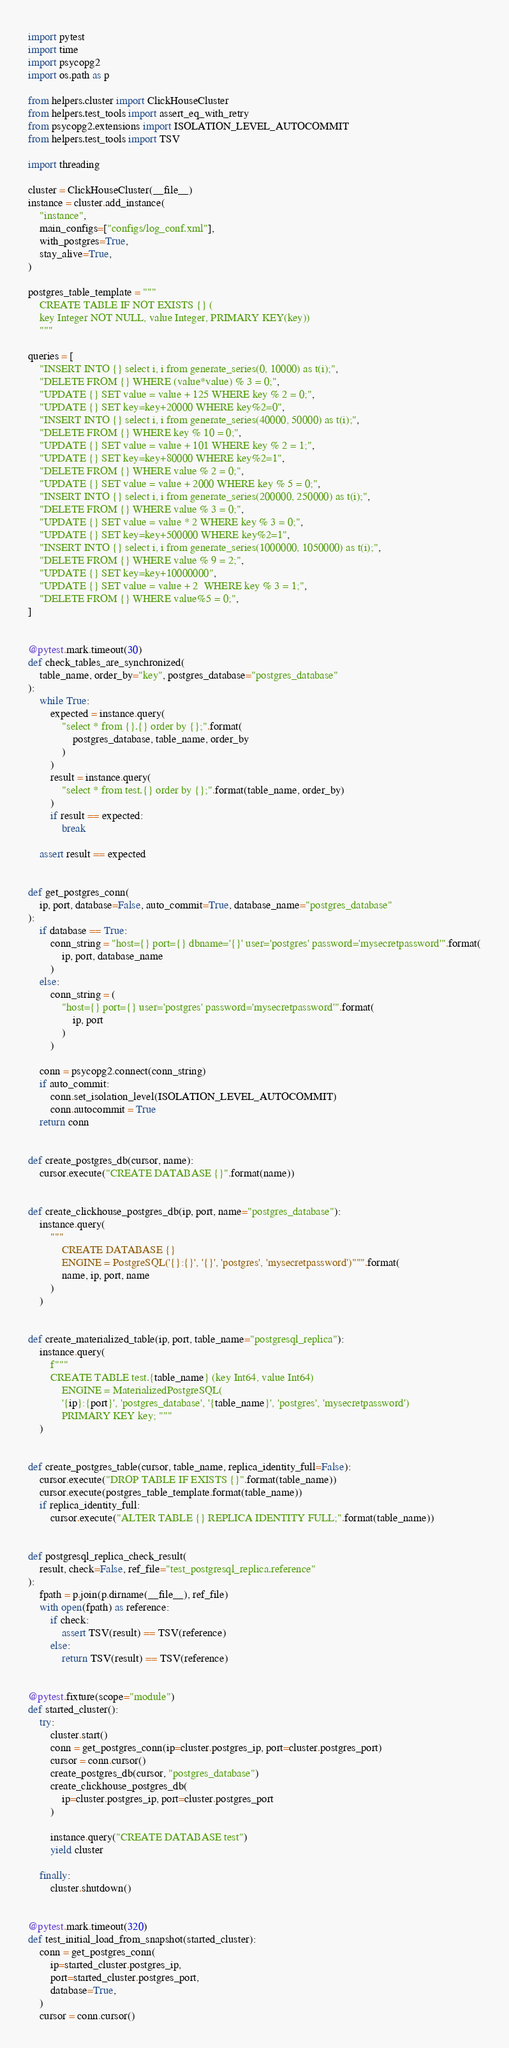<code> <loc_0><loc_0><loc_500><loc_500><_Python_>import pytest
import time
import psycopg2
import os.path as p

from helpers.cluster import ClickHouseCluster
from helpers.test_tools import assert_eq_with_retry
from psycopg2.extensions import ISOLATION_LEVEL_AUTOCOMMIT
from helpers.test_tools import TSV

import threading

cluster = ClickHouseCluster(__file__)
instance = cluster.add_instance(
    "instance",
    main_configs=["configs/log_conf.xml"],
    with_postgres=True,
    stay_alive=True,
)

postgres_table_template = """
    CREATE TABLE IF NOT EXISTS {} (
    key Integer NOT NULL, value Integer, PRIMARY KEY(key))
    """

queries = [
    "INSERT INTO {} select i, i from generate_series(0, 10000) as t(i);",
    "DELETE FROM {} WHERE (value*value) % 3 = 0;",
    "UPDATE {} SET value = value + 125 WHERE key % 2 = 0;",
    "UPDATE {} SET key=key+20000 WHERE key%2=0",
    "INSERT INTO {} select i, i from generate_series(40000, 50000) as t(i);",
    "DELETE FROM {} WHERE key % 10 = 0;",
    "UPDATE {} SET value = value + 101 WHERE key % 2 = 1;",
    "UPDATE {} SET key=key+80000 WHERE key%2=1",
    "DELETE FROM {} WHERE value % 2 = 0;",
    "UPDATE {} SET value = value + 2000 WHERE key % 5 = 0;",
    "INSERT INTO {} select i, i from generate_series(200000, 250000) as t(i);",
    "DELETE FROM {} WHERE value % 3 = 0;",
    "UPDATE {} SET value = value * 2 WHERE key % 3 = 0;",
    "UPDATE {} SET key=key+500000 WHERE key%2=1",
    "INSERT INTO {} select i, i from generate_series(1000000, 1050000) as t(i);",
    "DELETE FROM {} WHERE value % 9 = 2;",
    "UPDATE {} SET key=key+10000000",
    "UPDATE {} SET value = value + 2  WHERE key % 3 = 1;",
    "DELETE FROM {} WHERE value%5 = 0;",
]


@pytest.mark.timeout(30)
def check_tables_are_synchronized(
    table_name, order_by="key", postgres_database="postgres_database"
):
    while True:
        expected = instance.query(
            "select * from {}.{} order by {};".format(
                postgres_database, table_name, order_by
            )
        )
        result = instance.query(
            "select * from test.{} order by {};".format(table_name, order_by)
        )
        if result == expected:
            break

    assert result == expected


def get_postgres_conn(
    ip, port, database=False, auto_commit=True, database_name="postgres_database"
):
    if database == True:
        conn_string = "host={} port={} dbname='{}' user='postgres' password='mysecretpassword'".format(
            ip, port, database_name
        )
    else:
        conn_string = (
            "host={} port={} user='postgres' password='mysecretpassword'".format(
                ip, port
            )
        )

    conn = psycopg2.connect(conn_string)
    if auto_commit:
        conn.set_isolation_level(ISOLATION_LEVEL_AUTOCOMMIT)
        conn.autocommit = True
    return conn


def create_postgres_db(cursor, name):
    cursor.execute("CREATE DATABASE {}".format(name))


def create_clickhouse_postgres_db(ip, port, name="postgres_database"):
    instance.query(
        """
            CREATE DATABASE {}
            ENGINE = PostgreSQL('{}:{}', '{}', 'postgres', 'mysecretpassword')""".format(
            name, ip, port, name
        )
    )


def create_materialized_table(ip, port, table_name="postgresql_replica"):
    instance.query(
        f"""
        CREATE TABLE test.{table_name} (key Int64, value Int64)
            ENGINE = MaterializedPostgreSQL(
            '{ip}:{port}', 'postgres_database', '{table_name}', 'postgres', 'mysecretpassword')
            PRIMARY KEY key; """
    )


def create_postgres_table(cursor, table_name, replica_identity_full=False):
    cursor.execute("DROP TABLE IF EXISTS {}".format(table_name))
    cursor.execute(postgres_table_template.format(table_name))
    if replica_identity_full:
        cursor.execute("ALTER TABLE {} REPLICA IDENTITY FULL;".format(table_name))


def postgresql_replica_check_result(
    result, check=False, ref_file="test_postgresql_replica.reference"
):
    fpath = p.join(p.dirname(__file__), ref_file)
    with open(fpath) as reference:
        if check:
            assert TSV(result) == TSV(reference)
        else:
            return TSV(result) == TSV(reference)


@pytest.fixture(scope="module")
def started_cluster():
    try:
        cluster.start()
        conn = get_postgres_conn(ip=cluster.postgres_ip, port=cluster.postgres_port)
        cursor = conn.cursor()
        create_postgres_db(cursor, "postgres_database")
        create_clickhouse_postgres_db(
            ip=cluster.postgres_ip, port=cluster.postgres_port
        )

        instance.query("CREATE DATABASE test")
        yield cluster

    finally:
        cluster.shutdown()


@pytest.mark.timeout(320)
def test_initial_load_from_snapshot(started_cluster):
    conn = get_postgres_conn(
        ip=started_cluster.postgres_ip,
        port=started_cluster.postgres_port,
        database=True,
    )
    cursor = conn.cursor()</code> 